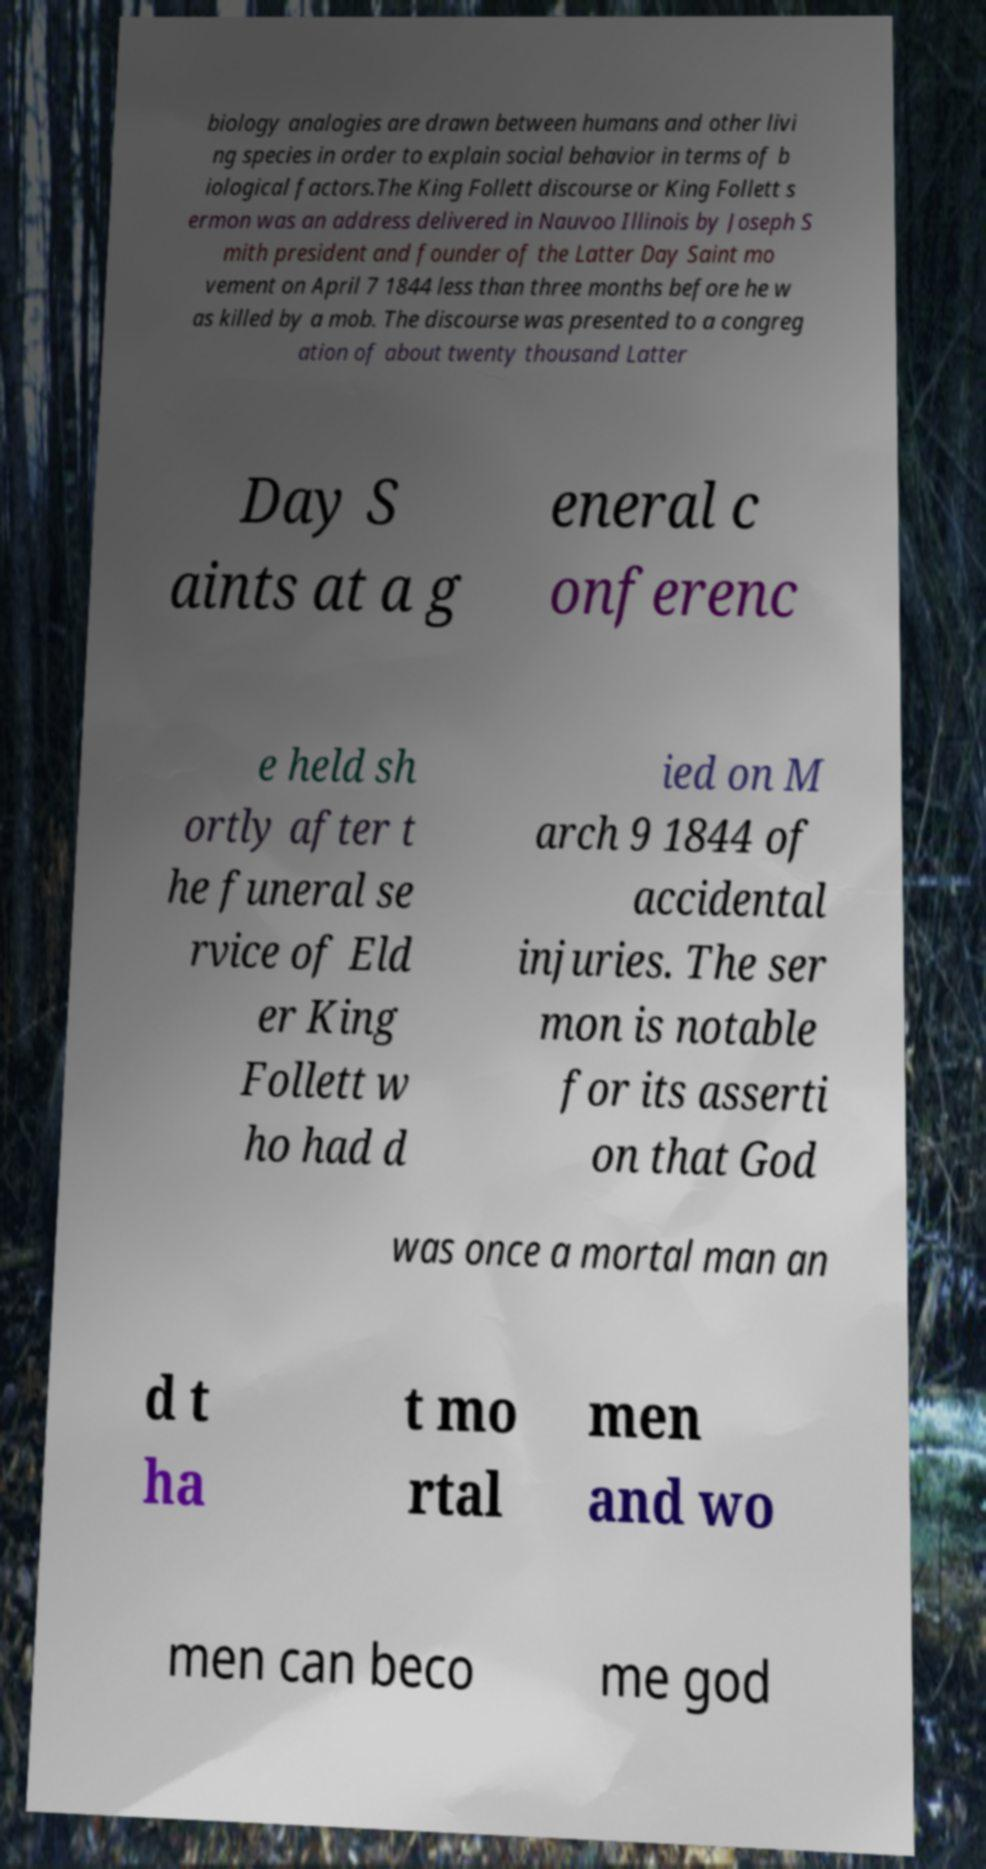What messages or text are displayed in this image? I need them in a readable, typed format. biology analogies are drawn between humans and other livi ng species in order to explain social behavior in terms of b iological factors.The King Follett discourse or King Follett s ermon was an address delivered in Nauvoo Illinois by Joseph S mith president and founder of the Latter Day Saint mo vement on April 7 1844 less than three months before he w as killed by a mob. The discourse was presented to a congreg ation of about twenty thousand Latter Day S aints at a g eneral c onferenc e held sh ortly after t he funeral se rvice of Eld er King Follett w ho had d ied on M arch 9 1844 of accidental injuries. The ser mon is notable for its asserti on that God was once a mortal man an d t ha t mo rtal men and wo men can beco me god 